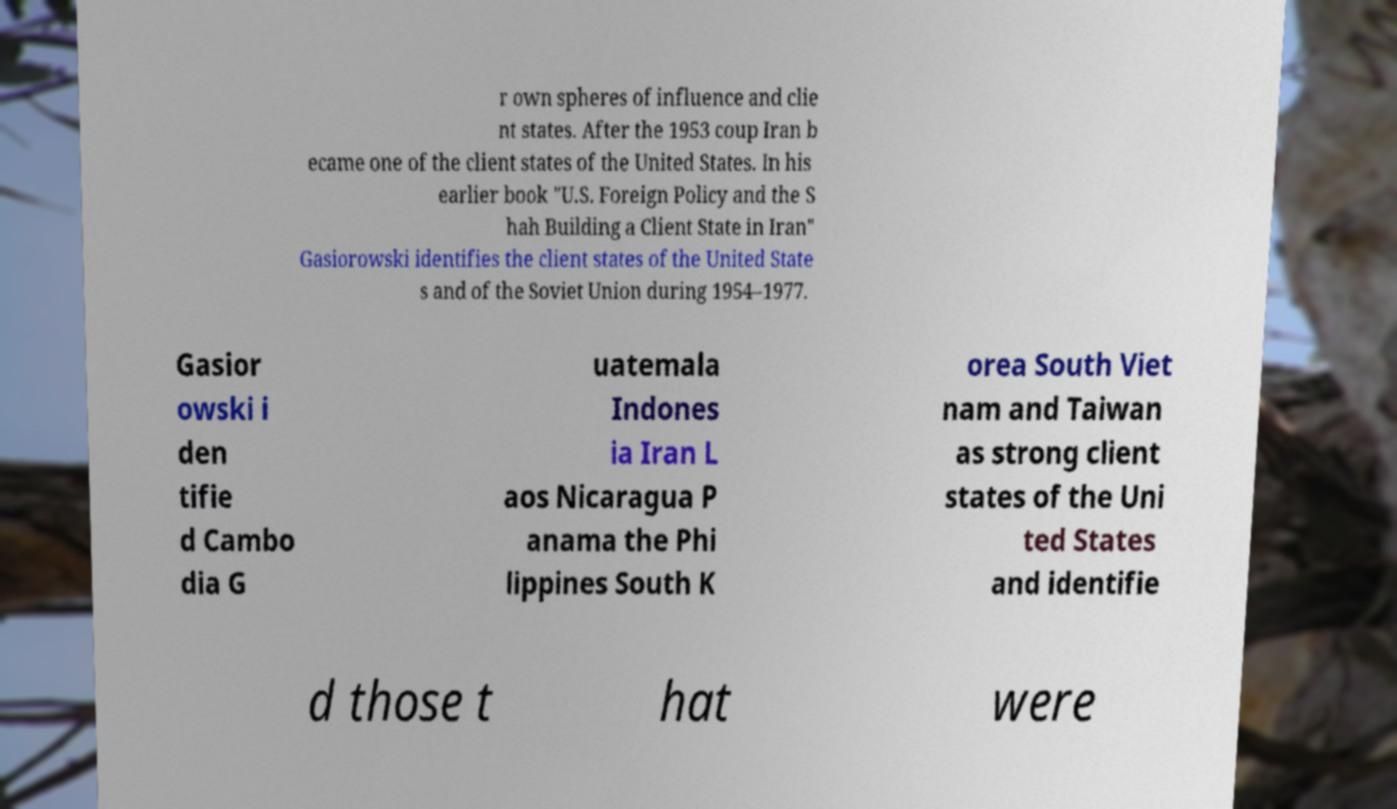Could you extract and type out the text from this image? r own spheres of influence and clie nt states. After the 1953 coup Iran b ecame one of the client states of the United States. In his earlier book "U.S. Foreign Policy and the S hah Building a Client State in Iran" Gasiorowski identifies the client states of the United State s and of the Soviet Union during 1954–1977. Gasior owski i den tifie d Cambo dia G uatemala Indones ia Iran L aos Nicaragua P anama the Phi lippines South K orea South Viet nam and Taiwan as strong client states of the Uni ted States and identifie d those t hat were 